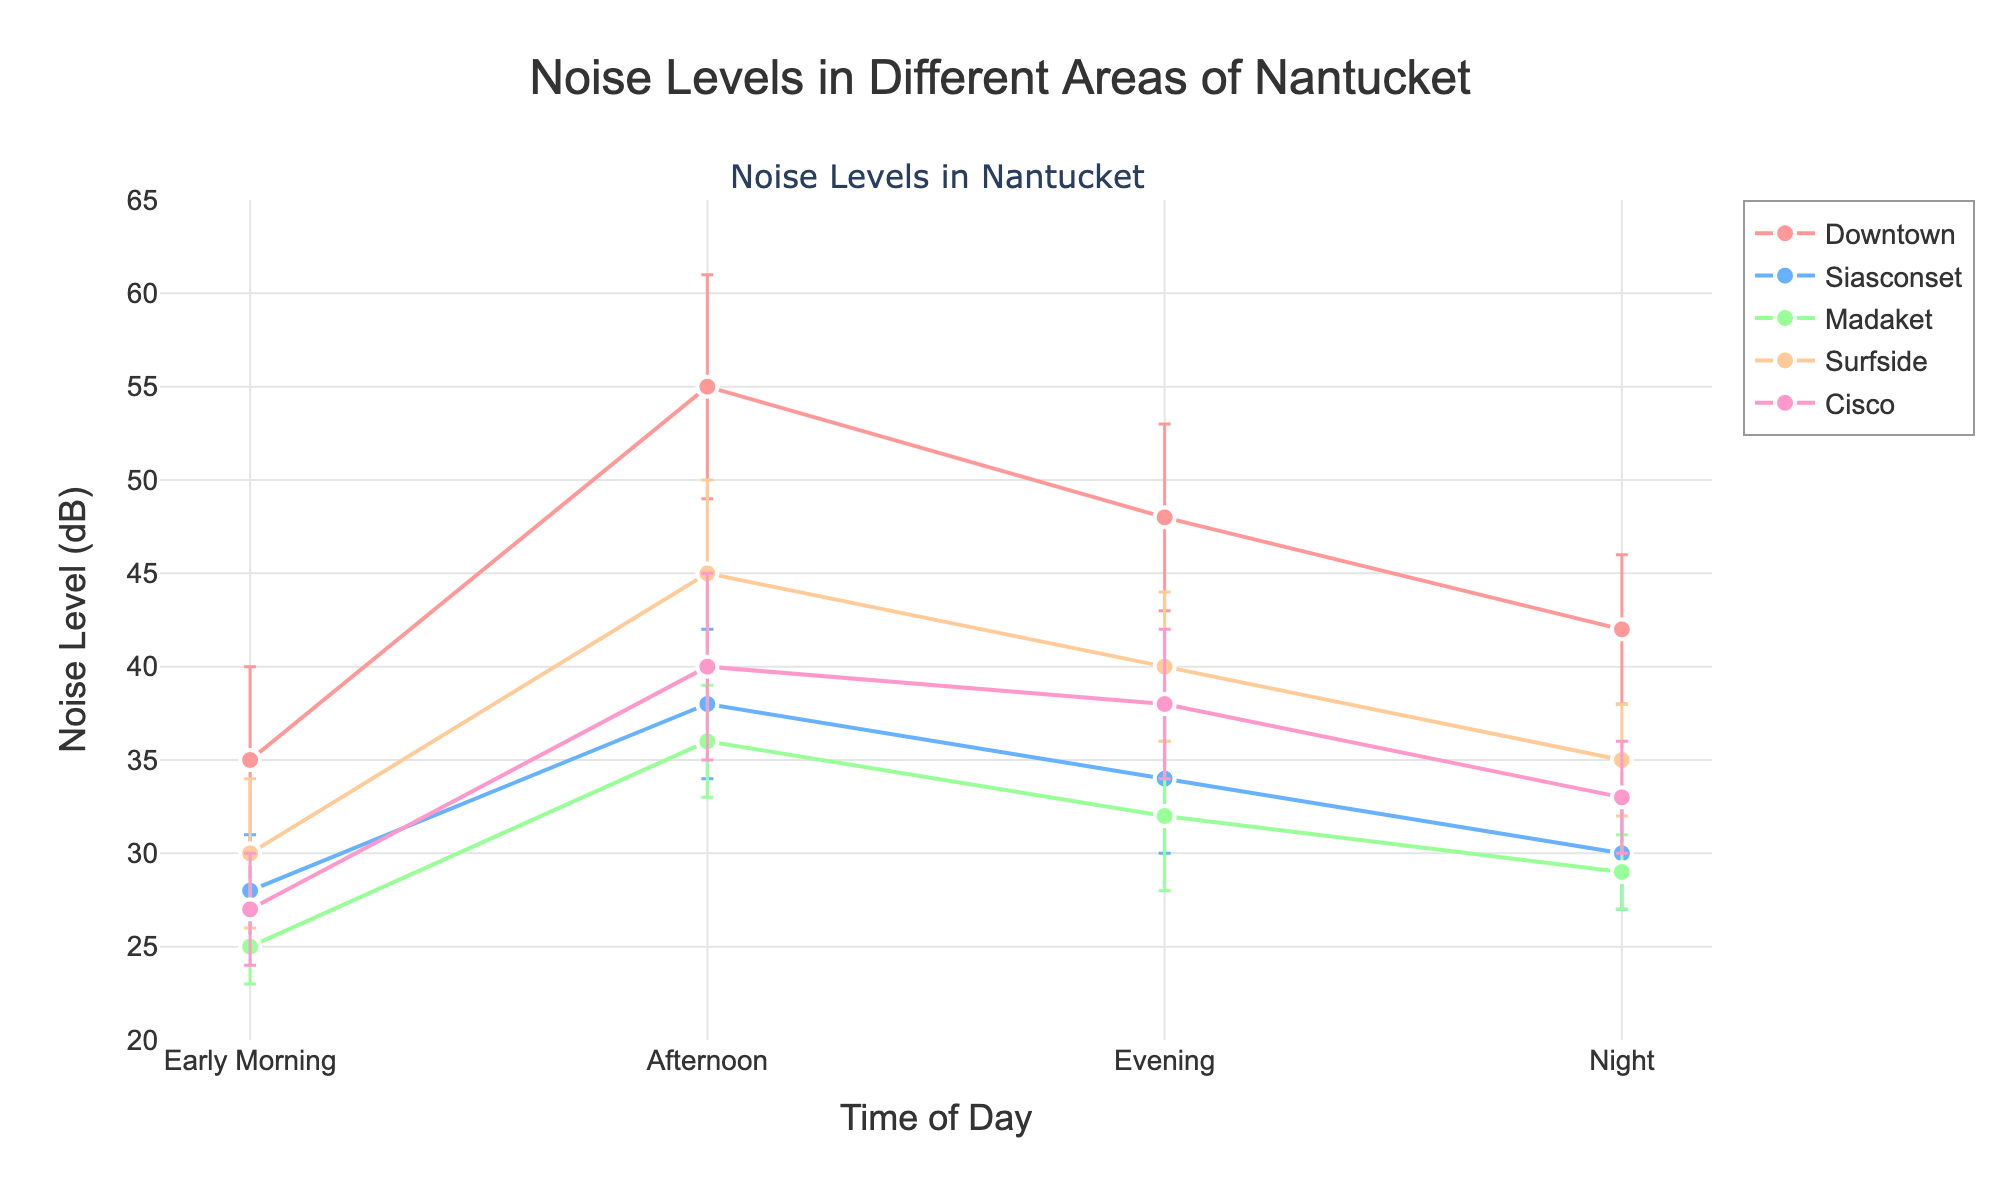What is the title of the figure? The title is usually placed at the top of the figure and provides a summary of what the figure represents. The title here is "Noise Levels in Different Areas of Nantucket".
Answer: Noise Levels in Different Areas of Nantucket Which location has the highest noise level in the evening? Look for the evening data point for each location, then identify which one has the largest noise level. According to the figure, Downtown has the highest noise level in the evening at 48 dB.
Answer: Downtown What are the error bars indicating for each data point? Error bars represent the uncertainty or variability in the measurements. The height of the error bars refers to the standard deviation or possible error in the noise level measurements. In this chart, error bars indicate the range of noise level measurements.
Answer: Uncertainty in noise level measurements At what time of day does Surfside have the lowest noise level? Examine the data points for Surfside. The noise level is the lowest in Early Morning with a value of 30 dB.
Answer: Early Morning Which location shows the most significant increase in noise level from Early Morning to Afternoon? Calculate the difference in noise level between Early Morning and Afternoon for each location. Downtown shows the most significant increase, going from 35 dB in Early Morning to 55 dB in the Afternoon, a difference of 20 dB.
Answer: Downtown Compare the noise levels between Madaket and Cisco during the Evening. Which location is louder and by how much? Look at the noise levels for both Madaket and Cisco in the Evening. Madaket has 32 dB while Cisco has 38 dB. Cisco is louder by 6 dB.
Answer: Cisco, 6 dB What is the range of noise levels observed in Siasconset throughout the day? The range is the difference between the maximum and minimum values. For Siasconset, the noise levels are 28 dB (Early Morning) to 38 dB (Afternoon). The range is 38 - 28 = 10 dB.
Answer: 10 dB Which location has the smallest error in noise level measurements during the Afternoon? Look at the error bars (uncertainty) for each location in the Afternoon. Madaket has the smallest error in the Afternoon with an error of 3 dB.
Answer: Madaket Is there any time of day when all locations have noise levels below 40 dB? Examine the noise levels for all locations at each time of day. No time of day has all locations below 40 dB. The closest is Early Morning, but Downtown exceeds 40 dB in the Afternoon.
Answer: No 